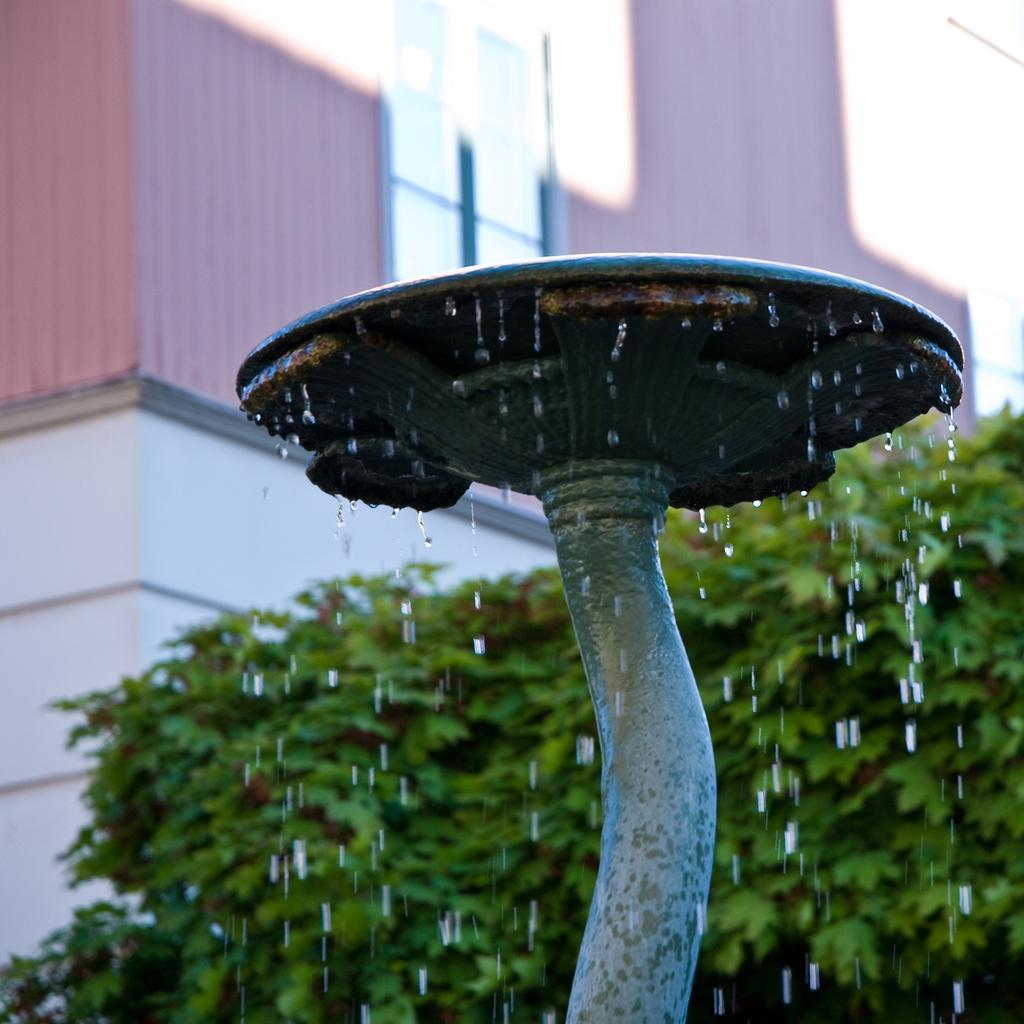Could you give a brief overview of what you see in this image? There is a pipe with a round shaped thing. From that water is falling. In the background there is building and trees. 